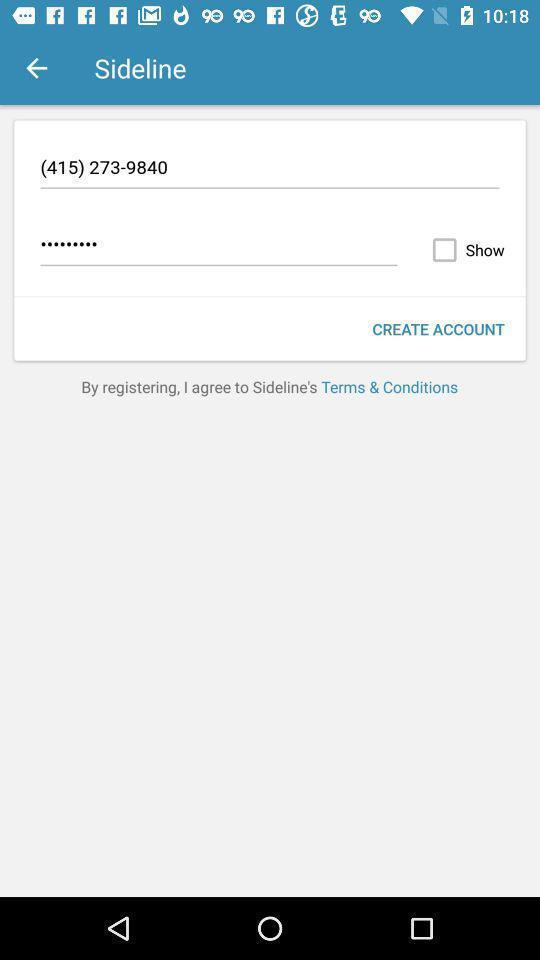Describe the key features of this screenshot. Page with contact details. 